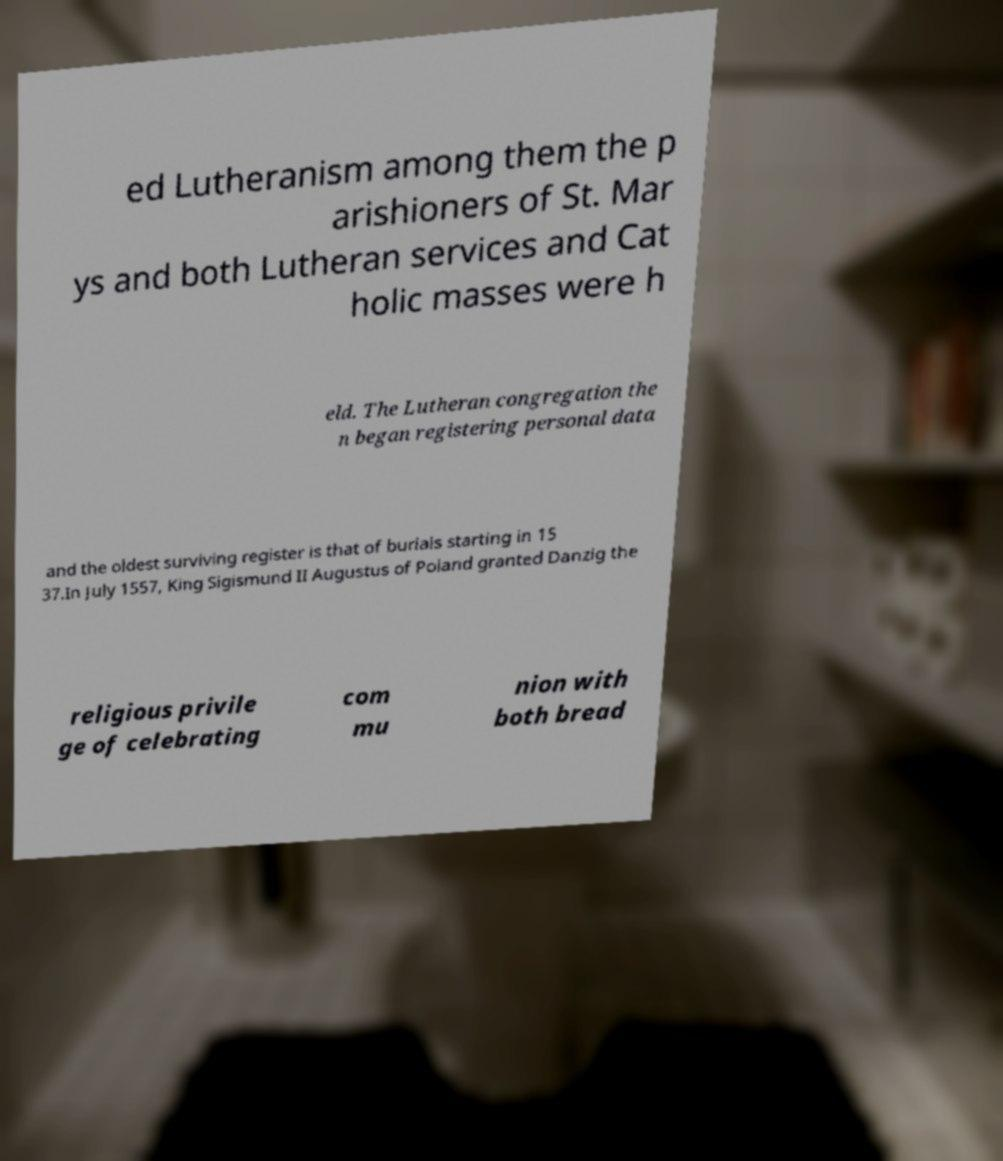Could you extract and type out the text from this image? ed Lutheranism among them the p arishioners of St. Mar ys and both Lutheran services and Cat holic masses were h eld. The Lutheran congregation the n began registering personal data and the oldest surviving register is that of burials starting in 15 37.In July 1557, King Sigismund II Augustus of Poland granted Danzig the religious privile ge of celebrating com mu nion with both bread 